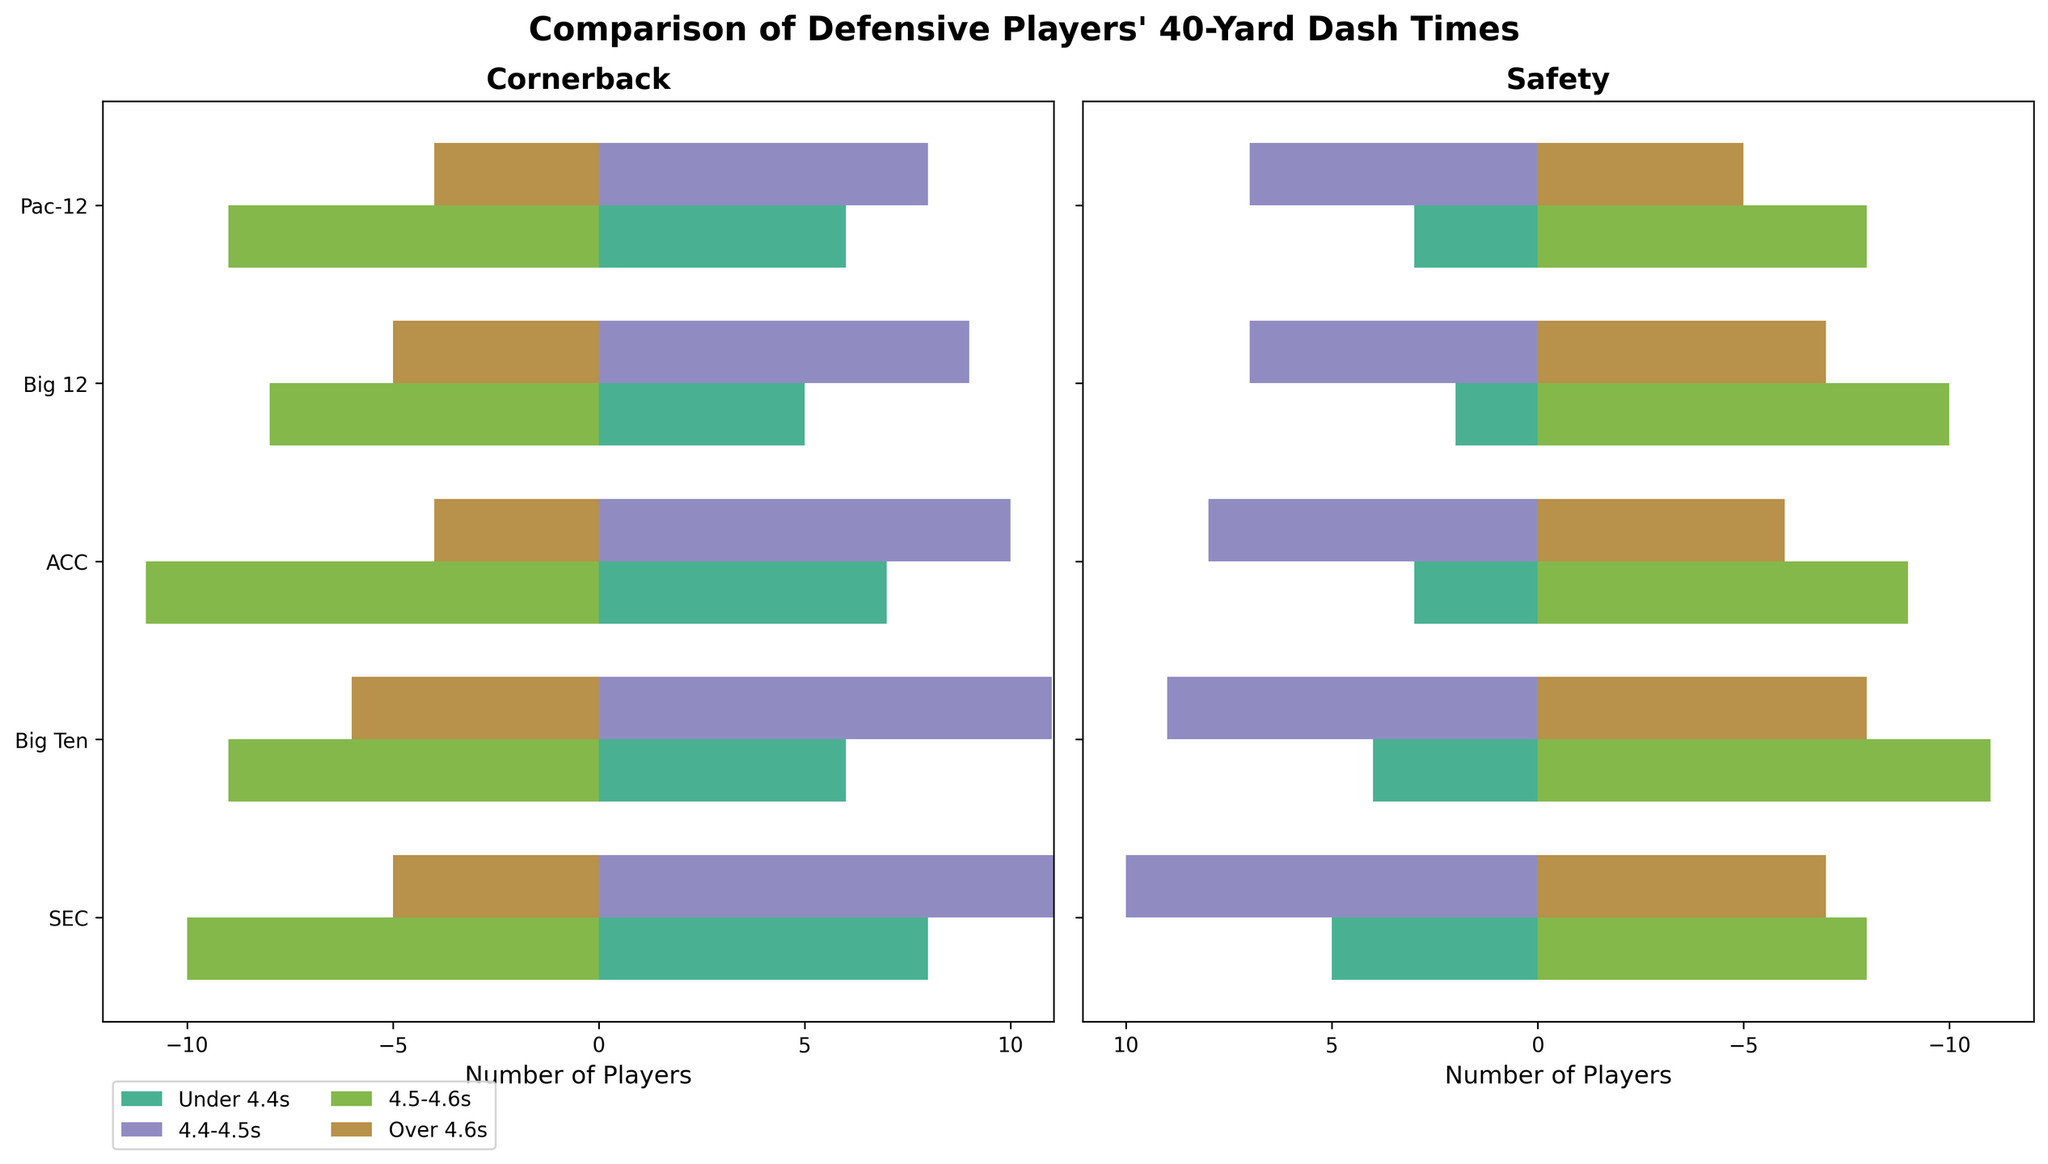What is the title of the figure? The figure has a title at the top, which is mentioned in a larger, bold font compared to other texts. It reads "Comparison of Defensive Players' 40-Yard Dash Times."
Answer: Comparison of Defensive Players' 40-Yard Dash Times Which position has more players in the 'Under 4.4s' category, Cornerback or Safety in the SEC conference? Look at the first subplot (Cornerback) and the second subplot (Safety) for the SEC conference. The Cornerback position has 8 players, while the Safety position has 5 players in the 'Under 4.4s' category. 8 is greater than 5.
Answer: Cornerback What is the difference in the number of Cornerbacks with dash times between '4.5-4.6s' and 'Over 4.6s' categories in the Big 12 conference? In the first subplot, locate the Big 12 conference for the Cornerback position. For '4.5-4.6s', it has -8 players and for 'Over 4.6s', it has -5 players. The difference is calculated as -8 - (-5) = -3 players.
Answer: -3 Which conference has the highest number of Safeties in the '4.4-4.5s' dash time category? Check the second subplot (Safety) for the Safeties in the '4.4-4.5s' category. Compare the numbers across different conferences: SEC (10), Big Ten (9), ACC (8), Big 12 (7), Pac-12 (7). SEC has the highest number (10).
Answer: SEC Are there more Cornerbacks or Safeties in the 'Over 4.6s' category in the Big Ten conference? In both subplots, locate the Big Ten conference. For Cornerbacks, it shows -6 players, and for Safeties, it shows -8 players. -6 is less than -8, so there are more Safeties in the 'Over 4.6s' category.
Answer: Safeties How many total SEC Cornerbacks have dash times less than 4.5s? For the SEC conference in the first subplot (Cornerback), add the numbers in 'Under 4.4s' and '4.4-4.5s' categories: 8 players + 12 players = 20 players.
Answer: 20 Which conference has the fewest number of players in the 'Under 4.4s' and '4.4-4.5s' categories combined for Safeties? For the second subplot (Safety), sum the values in 'Under 4.4s' and '4.4-4.5s' for each conference: SEC (5+10=15), Big Ten (4+9=13), ACC (3+8=11), Big 12 (2+7=9), Pac-12 (3+7=10). The Big 12 has the fewest (9).
Answer: Big 12 What is the total number of Cornerbacks in the '4.5-4.6s' category across all conferences? Sum the values in the '4.5-4.6s' category for Cornerbacks across all conferences: SEC (-10), Big Ten (-9), ACC (-11), Big 12 (-8), Pac-12 (-9). The total is -10 - 9 - 11 - 8 - 9 = -47.
Answer: -47 Which conference has more Speedy Cornerbacks (i.e., 'Under 4.4s' players): SEC or ACC? Compare the 'Under 4.4s' values for Cornerbacks in the SEC and ACC conferences. SEC has 8, and ACC has 7. 8 is greater than 7.
Answer: SEC 